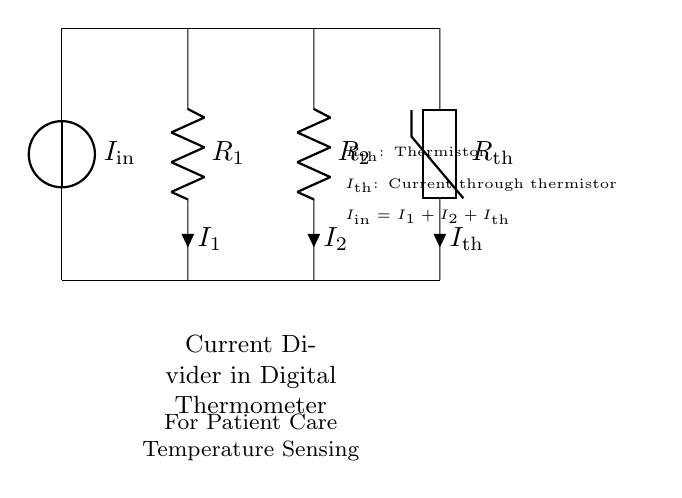What is the input current of the circuit? The input current is represented as I_in, which is the total current flowing into the current divider circuit. It can be observed at the voltage source.
Answer: I_in What are the resistances in the circuit? The circuit contains two resistors labeled R_1 and R_2, which are the resistive components of the current divider.
Answer: R_1 and R_2 Which component measures the temperature? The thermistor labeled R_th is the component that measures temperature in this circuit, as it is designated specifically for temperature sensing.
Answer: R_th What is the relationship between the currents I_1, I_2, and I_th? The relationship is given by the equation I_in = I_1 + I_2 + I_th, indicating that the input current splits into three components: I_1, I_2, and I_th through their respective branches.
Answer: I_1 + I_2 + I_th What happens to the input current in this circuit? The input current I_in is divided among two branches (resistors R_1 and R_2) and the thermistor branch, thus showing how current divider circuits distribute current.
Answer: It divides among R_1, R_2, and R_th How does the thermistor affect the current in the circuit? The thermistor R_th alters the current I_th based on the temperature changes, affecting how the input current I_in is divided and measured in this patient care application.
Answer: It alters I_th based on temperature 